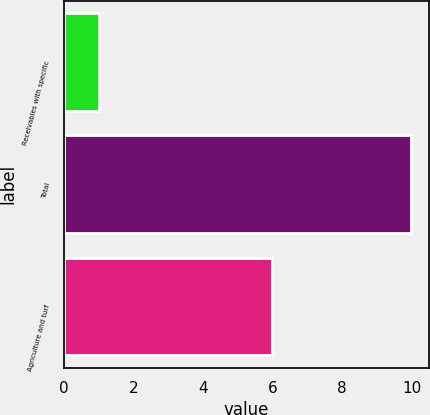<chart> <loc_0><loc_0><loc_500><loc_500><bar_chart><fcel>Receivables with specific<fcel>Total<fcel>Agriculture and turf<nl><fcel>1<fcel>10<fcel>6<nl></chart> 